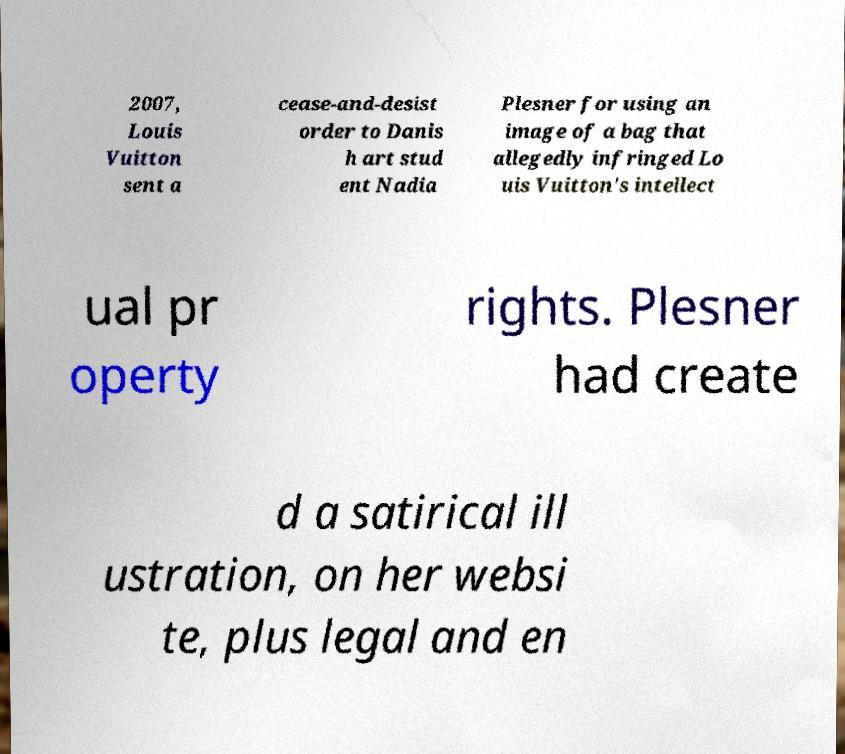Can you read and provide the text displayed in the image?This photo seems to have some interesting text. Can you extract and type it out for me? 2007, Louis Vuitton sent a cease-and-desist order to Danis h art stud ent Nadia Plesner for using an image of a bag that allegedly infringed Lo uis Vuitton's intellect ual pr operty rights. Plesner had create d a satirical ill ustration, on her websi te, plus legal and en 